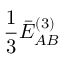Convert formula to latex. <formula><loc_0><loc_0><loc_500><loc_500>\frac { 1 } { 3 } \bar { E } _ { A B } ^ { ( 3 ) }</formula> 